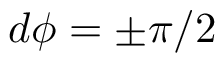<formula> <loc_0><loc_0><loc_500><loc_500>d \phi = \pm \pi / 2</formula> 